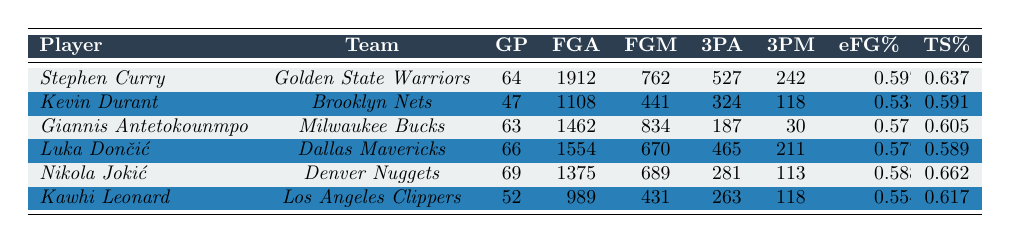What is Stephen Curry's effective field goal percentage? According to the table, Stephen Curry's effective field goal percentage is listed under the "eFG%" column, which shows a value of 0.597.
Answer: 0.597 How many total field goals did Kevin Durant make? The number of field goals Kevin Durant made can be found in the "FGM" column, which shows a total of 441 field goals.
Answer: 441 Which player has the highest true shooting percentage? By examining the "TS%" column, Nikola Jokić has the highest true shooting percentage of 0.662 among all players listed.
Answer: Nikola Jokić What is the average effective field goal percentage of all players? To find the average effective field goal percentage, add all the eFG% values (0.597, 0.533, 0.571, 0.577, 0.588, 0.554) and divide by the number of players (6). The sum is 3.420, and the average is 3.420 / 6 = 0.57.
Answer: 0.57 How many more three-point shots did Luka Dončić make compared to Kawhi Leonard? Luka Dončić made 211 three-point shots (3PM), and Kawhi Leonard made 118. The difference is 211 - 118 = 93.
Answer: 93 Is Giannis Antetokounmpo's effective field goal percentage greater than 0.55? Giannis's effective field goal percentage is 0.571, which is indeed greater than 0.55.
Answer: Yes What is the combined total of field goals attempted by Nikola Jokić and Kevin Durant? Nikola Jokić attempted 1375 field goals and Kevin Durant attempted 1108 field goals. Adding these two values gives 1375 + 1108 = 2483.
Answer: 2483 Which player has the lowest three-point shooting percentage? To find the lowest three-point shooting percentage, divide the number of three-pointers made by the number attempted for each player. Giannis Antetokounmpo made 30 of 187, giving 30/187 ≈ 0.160, which is lower than the others.
Answer: Giannis Antetokounmpo What is Stephen Curry's total field goals made minus field goals attempted? Stephen Curry made 762 field goals and attempted 1912. The difference is 762 - 1912 = -1150, indicating he attempted more than he made.
Answer: -1150 Who has played the most games in the table? The player with the most games played is Nikola Jokić with 69 games.
Answer: Nikola Jokić 